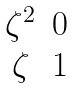Convert formula to latex. <formula><loc_0><loc_0><loc_500><loc_500>\begin{matrix} \zeta ^ { 2 } & 0 \\ \zeta & 1 \end{matrix}</formula> 